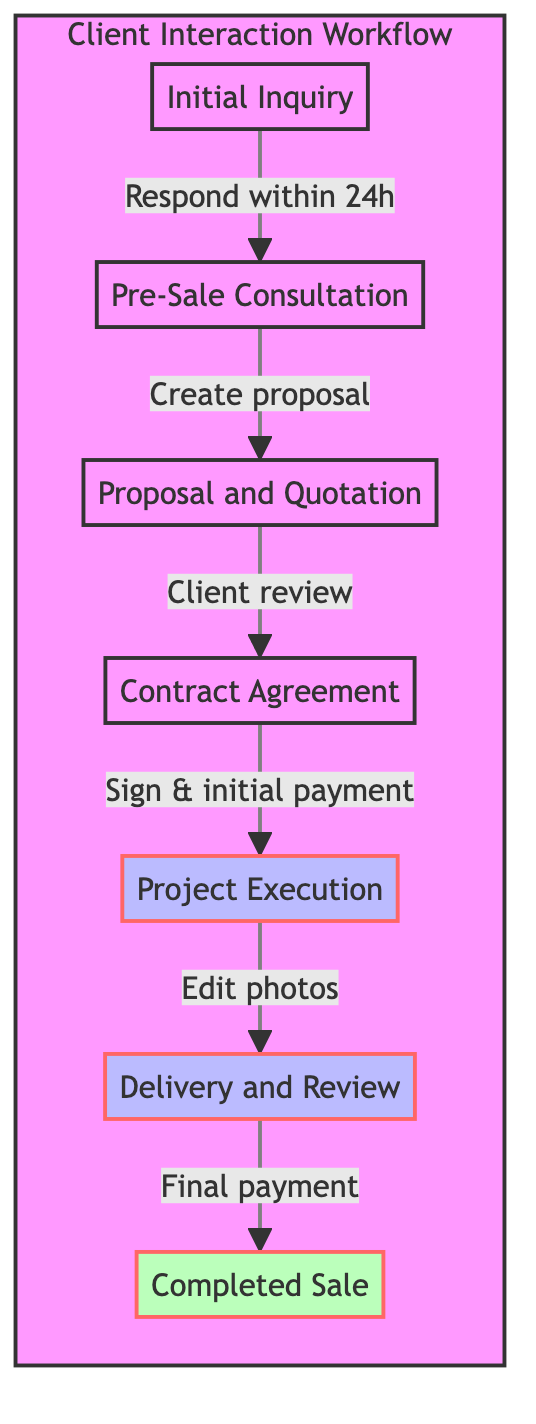What is the first stage in the workflow? The first stage in the workflow is labeled "Initial Inquiry." It is the starting point where potential clients reach out.
Answer: Initial Inquiry How many actions are listed under the "Delivery and Review" stage? In the "Delivery and Review" stage, there are three actions: sending edited photos, requesting client feedback, and making revisions. Counting these actions gives a total of three.
Answer: 3 What is the action taken after the "Proposal and Quotation" stage? Following the "Proposal and Quotation" stage, the next action is related to "Contract Agreement," which involves the client reviewing the proposal.
Answer: Contract Agreement Which stage follows "Project Execution"? After "Project Execution," the next stage is "Delivery and Review." This indicates a sequence where the project execution is followed by delivering the completed work to the client.
Answer: Delivery and Review In which stage does the final payment occur? The final payment occurs during the "Completed Sale" stage, which indicates the closure of the payment process after delivering the service.
Answer: Completed Sale How are initial inquiries identified in the diagram? Initial inquiries are depicted as the starting point labeled "Initial Inquiry," where potential clients make contact through email or social media.
Answer: Initial Inquiry What happens after the client signs the contract? After the client signs the contract, the next action taken is the "Project Execution," meaning the project starts being carried out based on the agreed terms.
Answer: Project Execution Which nodes are connected by the edge labeled "Create proposal"? The edge labeled "Create proposal" connects the "Pre-Sale Consultation" node to the "Proposal and Quotation" node, indicating that the proposal creation follows the consultation.
Answer: Proposal and Quotation How many total stages are represented in the workflow? There are seven total stages represented in the workflow, as outlined from "Initial Inquiry" to "Completed Sale." Counting each stage results in seven distinct sections.
Answer: 7 What stage involves understanding the client's needs? The stage that involves understanding the client's needs is "Pre-Sale Consultation," where discussions about project requirements take place.
Answer: Pre-Sale Consultation 